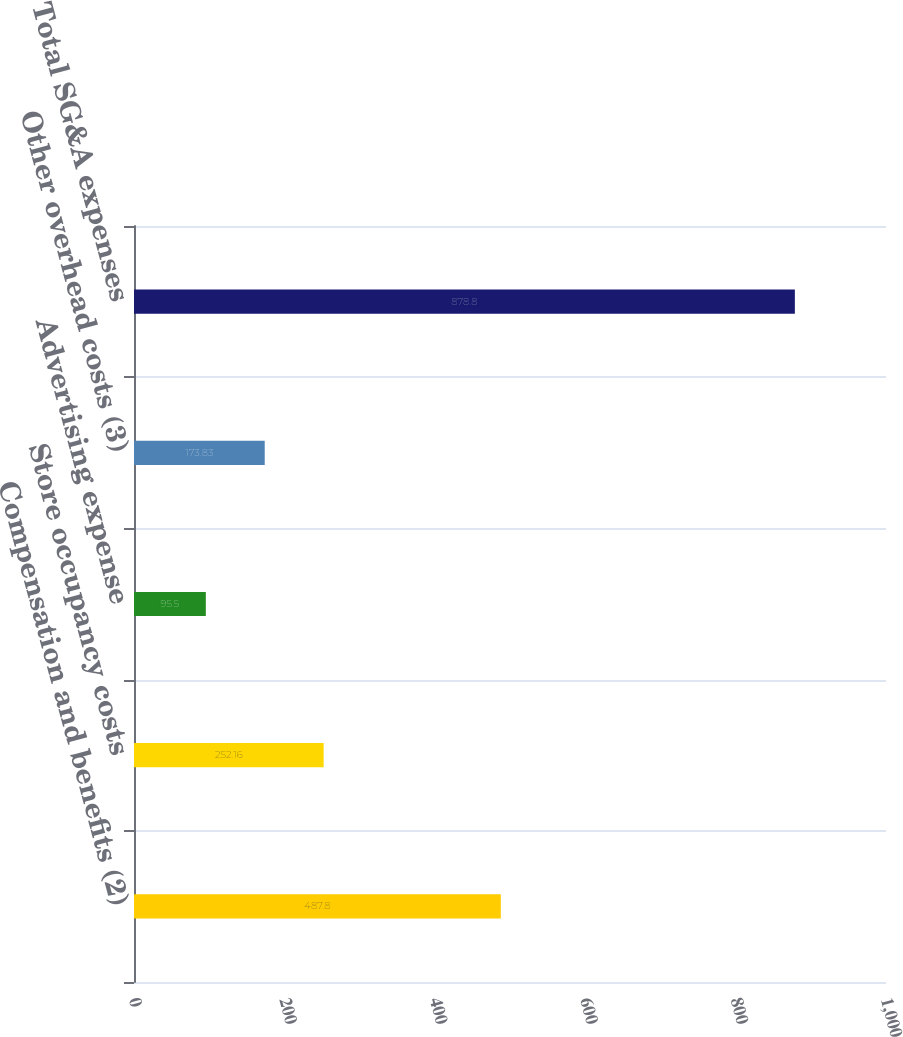<chart> <loc_0><loc_0><loc_500><loc_500><bar_chart><fcel>Compensation and benefits (2)<fcel>Store occupancy costs<fcel>Advertising expense<fcel>Other overhead costs (3)<fcel>Total SG&A expenses<nl><fcel>487.8<fcel>252.16<fcel>95.5<fcel>173.83<fcel>878.8<nl></chart> 